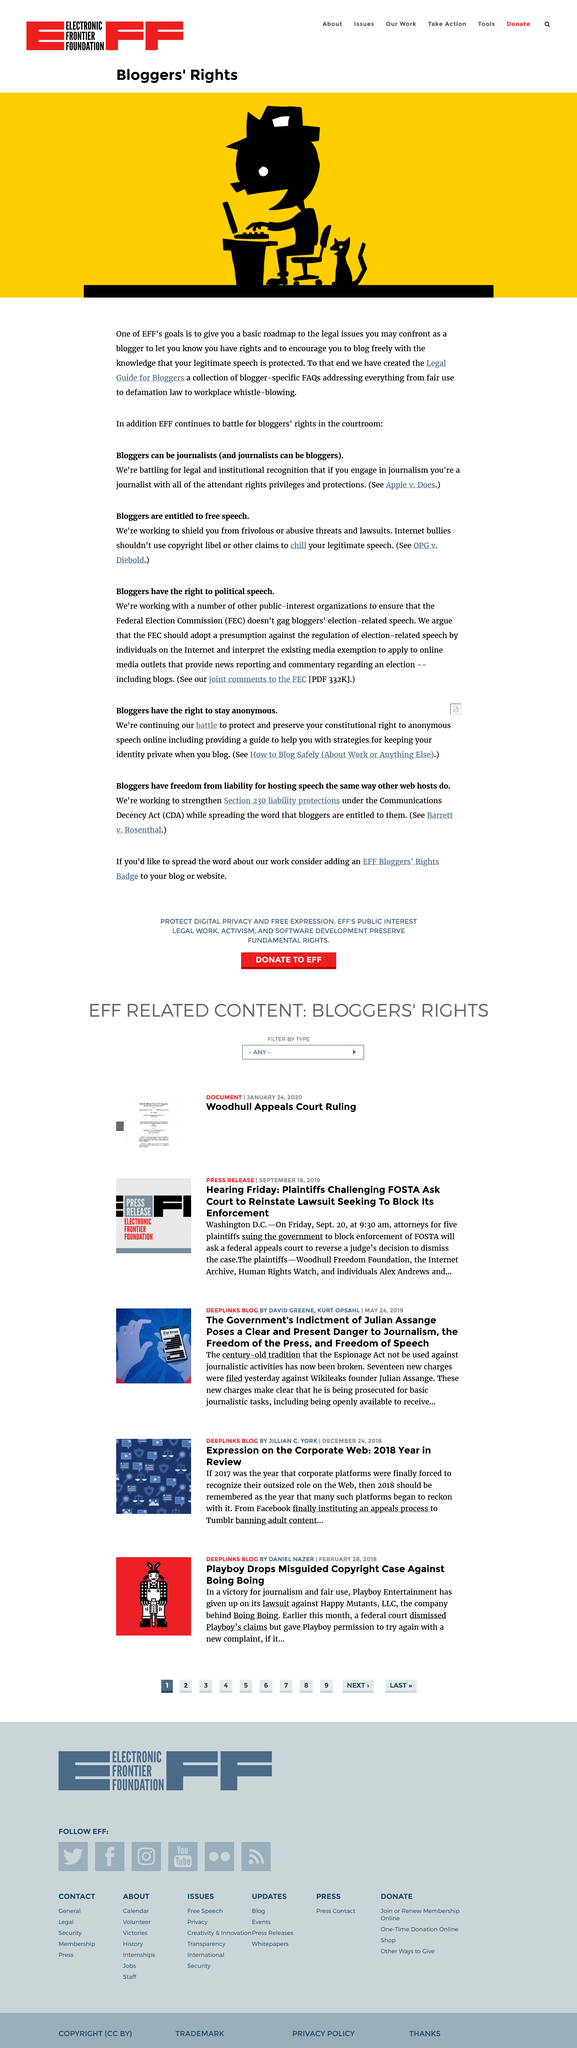Draw attention to some important aspects in this diagram. They have not only fought for what is right on the internet but also in the courtroom. They, the creators of the Legal Guide for Bloggers, have successfully brought into existence a comprehensive resource for bloggers seeking legal guidance. Bloggers can be journalists, therefore, they can be whatever they aspire to be. 